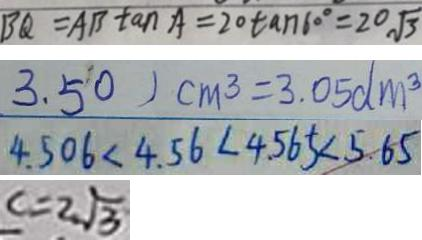<formula> <loc_0><loc_0><loc_500><loc_500>B Q = A B \tan A = 2 0 \tan 6 0 ^ { \circ } = 2 0 \sqrt { 3 } 
 3 . 5 0 ) c m ^ { 3 } = 3 . 0 5 d m ^ { 3 } 
 4 . 5 0 6 < 4 . 5 6 < 4 . 5 6 5 < 5 . 6 5 
 c = 2 \sqrt { 3 }</formula> 